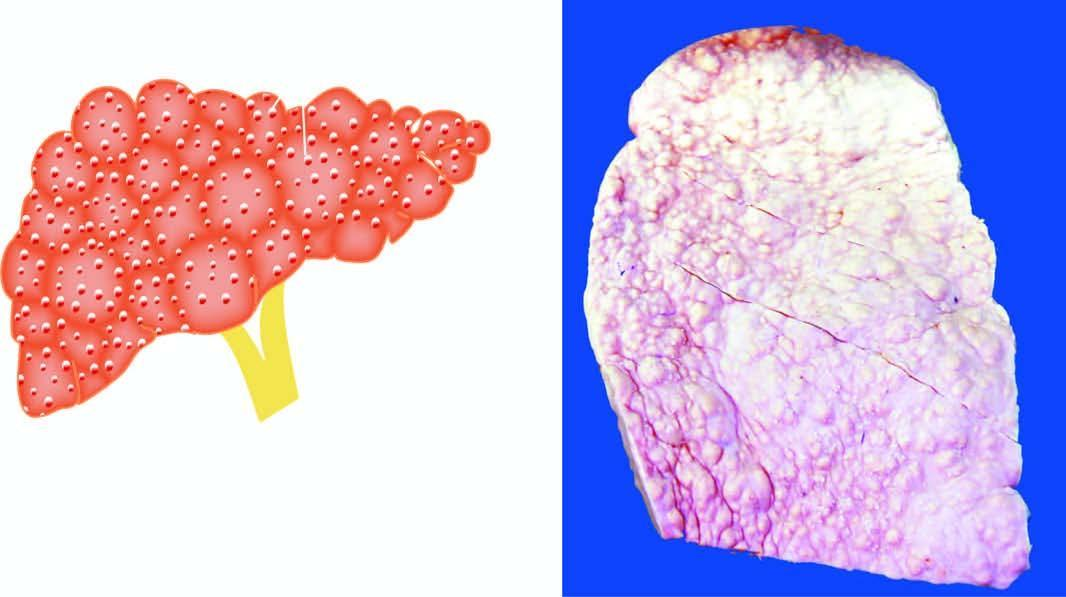s the liver small, distorted and irregularly scarred?
Answer the question using a single word or phrase. Yes 